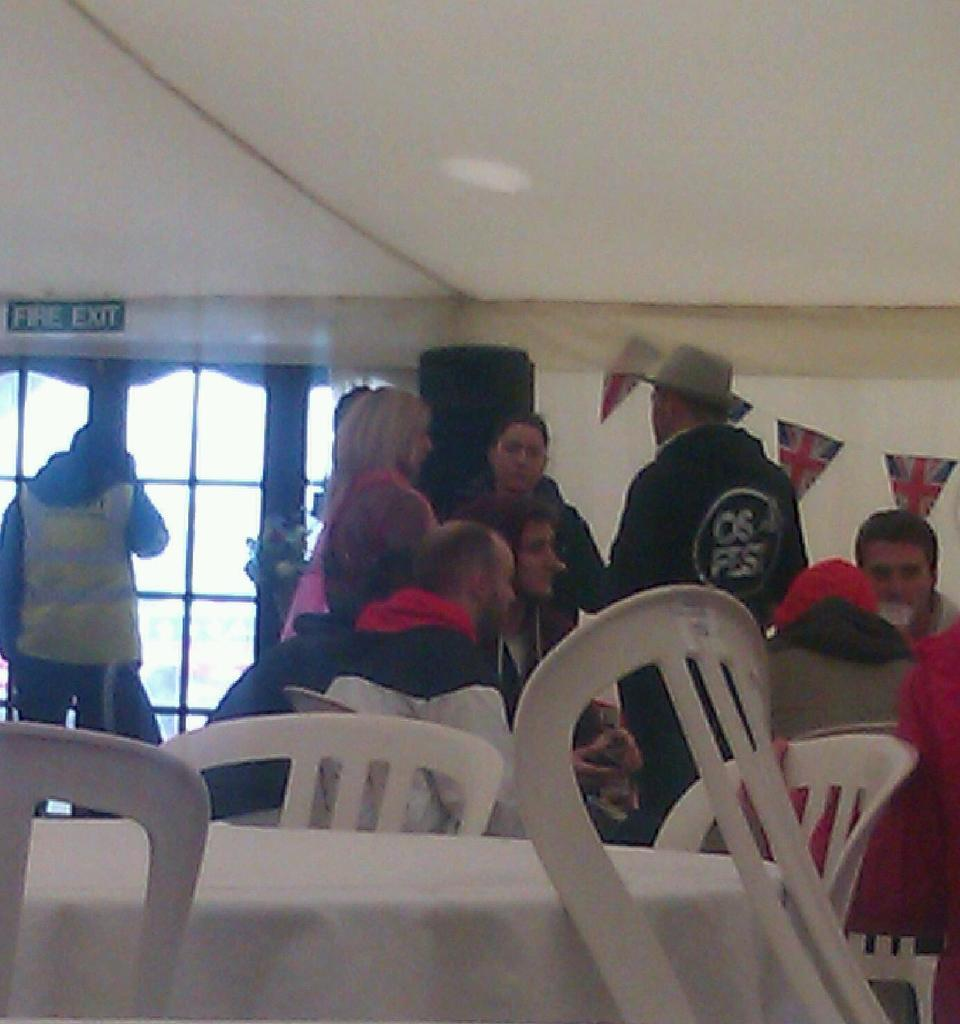What are the people in the image doing? There are people sitting and standing in the image. Can you describe the location of the fire exit in the image? The fire exit is visible in the image. How many buttons can be seen on the bikes in the image? There are no bikes present in the image, so there are no buttons to count. What type of star is visible in the image? There is no star visible in the image. 